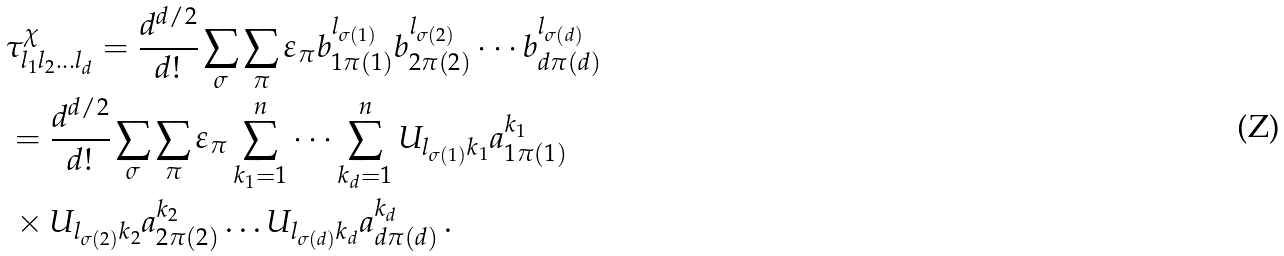Convert formula to latex. <formula><loc_0><loc_0><loc_500><loc_500>& \tau ^ { \chi } _ { l _ { 1 } l _ { 2 } \dots l _ { d } } = \frac { d ^ { d / 2 } } { d ! } \sum _ { \sigma } \sum _ { \pi } { \varepsilon } _ { \pi } b _ { 1 \pi ( 1 ) } ^ { l _ { \sigma ( 1 ) } } b _ { 2 \pi ( 2 ) } ^ { l _ { \sigma ( 2 ) } } \cdots b _ { d \pi ( d ) } ^ { l _ { \sigma ( d ) } } \\ & = \frac { d ^ { d / 2 } } { d ! } \sum _ { \sigma } \sum _ { \pi } { \varepsilon } _ { \pi } \sum _ { k _ { 1 } = 1 } ^ { n } \cdots \sum _ { k _ { d } = 1 } ^ { n } U _ { l _ { \sigma ( 1 ) } k _ { 1 } } a _ { 1 \pi ( 1 ) } ^ { k _ { 1 } } \\ & \, \times U _ { l _ { \sigma ( 2 ) } k _ { 2 } } a _ { 2 \pi ( 2 ) } ^ { k _ { 2 } } \dots U _ { l _ { \sigma ( d ) } k _ { d } } a _ { d \pi ( d ) } ^ { k _ { d } } \, .</formula> 